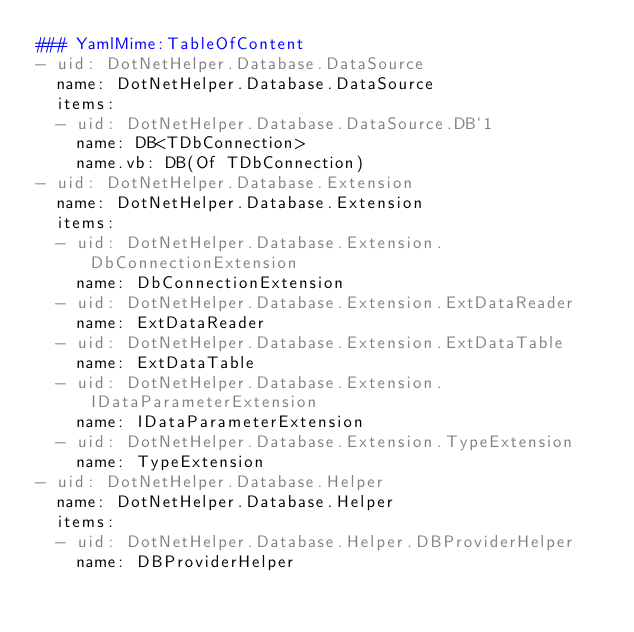Convert code to text. <code><loc_0><loc_0><loc_500><loc_500><_YAML_>### YamlMime:TableOfContent
- uid: DotNetHelper.Database.DataSource
  name: DotNetHelper.Database.DataSource
  items:
  - uid: DotNetHelper.Database.DataSource.DB`1
    name: DB<TDbConnection>
    name.vb: DB(Of TDbConnection)
- uid: DotNetHelper.Database.Extension
  name: DotNetHelper.Database.Extension
  items:
  - uid: DotNetHelper.Database.Extension.DbConnectionExtension
    name: DbConnectionExtension
  - uid: DotNetHelper.Database.Extension.ExtDataReader
    name: ExtDataReader
  - uid: DotNetHelper.Database.Extension.ExtDataTable
    name: ExtDataTable
  - uid: DotNetHelper.Database.Extension.IDataParameterExtension
    name: IDataParameterExtension
  - uid: DotNetHelper.Database.Extension.TypeExtension
    name: TypeExtension
- uid: DotNetHelper.Database.Helper
  name: DotNetHelper.Database.Helper
  items:
  - uid: DotNetHelper.Database.Helper.DBProviderHelper
    name: DBProviderHelper
</code> 